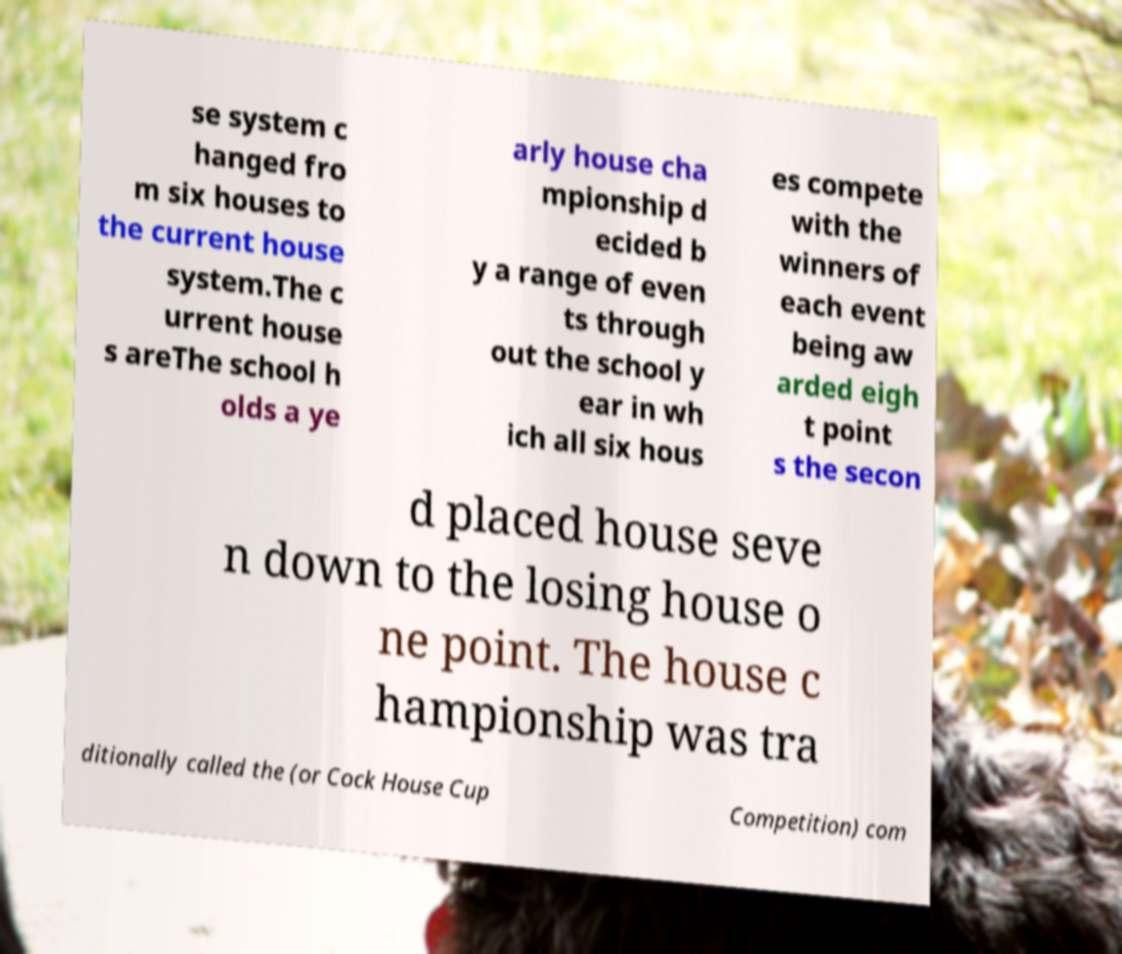Can you accurately transcribe the text from the provided image for me? se system c hanged fro m six houses to the current house system.The c urrent house s areThe school h olds a ye arly house cha mpionship d ecided b y a range of even ts through out the school y ear in wh ich all six hous es compete with the winners of each event being aw arded eigh t point s the secon d placed house seve n down to the losing house o ne point. The house c hampionship was tra ditionally called the (or Cock House Cup Competition) com 